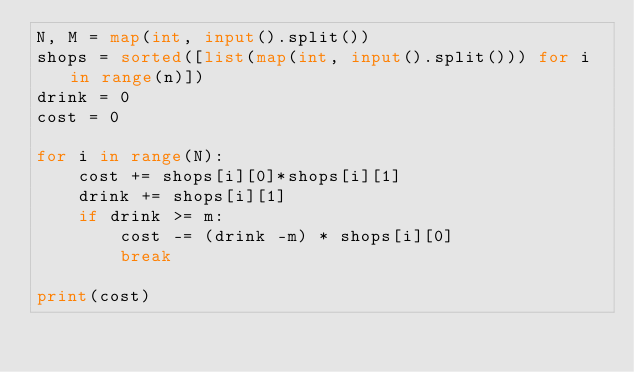<code> <loc_0><loc_0><loc_500><loc_500><_Python_>N, M = map(int, input().split())
shops = sorted([list(map(int, input().split())) for i in range(n)])
drink = 0
cost = 0

for i in range(N):
    cost += shops[i][0]*shops[i][1]
    drink += shops[i][1]
    if drink >= m:
        cost -= (drink -m) * shops[i][0]
        break
        
print(cost)
</code> 